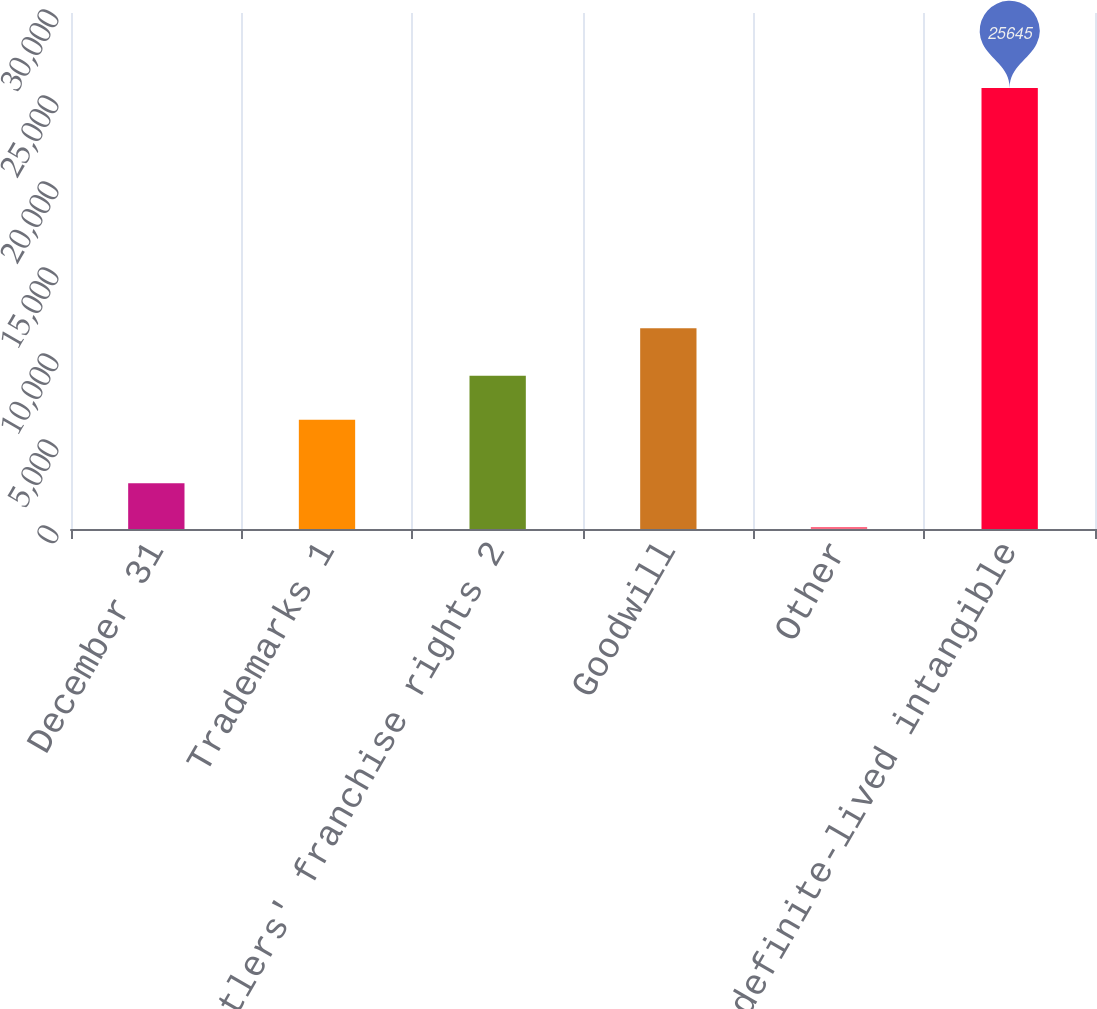Convert chart. <chart><loc_0><loc_0><loc_500><loc_500><bar_chart><fcel>December 31<fcel>Trademarks 1<fcel>Bottlers' franchise rights 2<fcel>Goodwill<fcel>Other<fcel>Indefinite-lived intangible<nl><fcel>2666.2<fcel>6356<fcel>8909.2<fcel>11665<fcel>113<fcel>25645<nl></chart> 